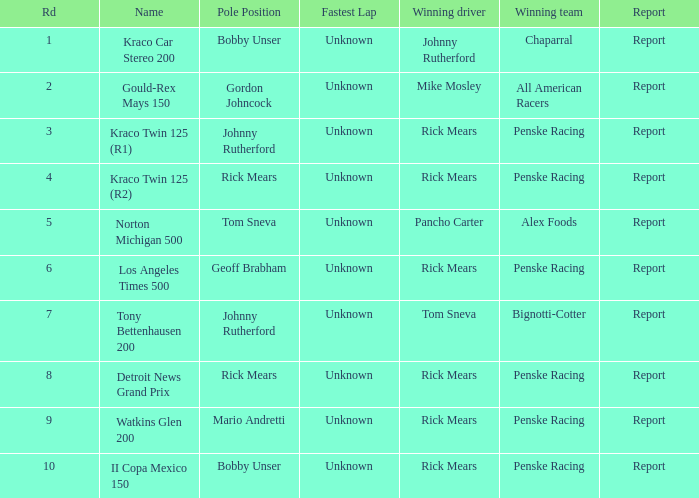How many fastest laps were there for a rd that equals 10? 1.0. 